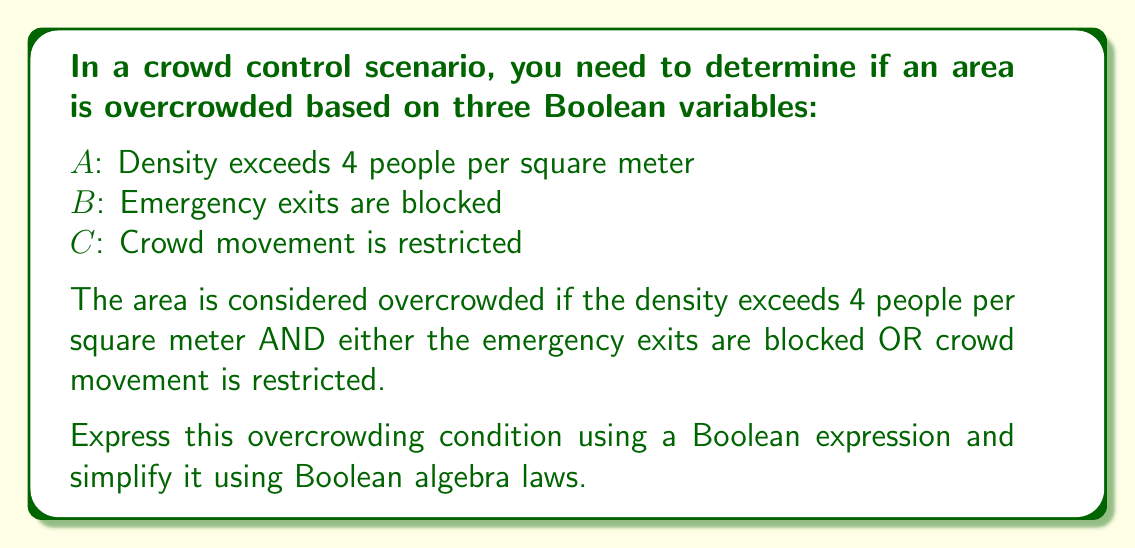Teach me how to tackle this problem. Let's approach this step-by-step:

1) First, we need to translate the given condition into a Boolean expression:

   Overcrowded = $A$ AND (($B$ OR $C$))

2) We can express this using Boolean algebra notation:

   $F = A \cdot (B + C)$

3) This expression is already in its simplest form, as it uses the distributive law of Boolean algebra. However, let's verify this:

4) If we were to distribute $A$, we would get:

   $F = (A \cdot B) + (A \cdot C)$

5) This is equivalent to our original expression, but not simpler. Therefore, the original expression $A \cdot (B + C)$ is the most simplified form.

6) In words, this expression means: The area is overcrowded (F is true) if and only if the density exceeds 4 people per square meter (A is true) AND either the emergency exits are blocked (B is true) OR crowd movement is restricted (C is true).

This Boolean expression effectively captures the crowd density threshold and additional risk factors for overcrowding in a concise mathematical form.
Answer: $A \cdot (B + C)$ 